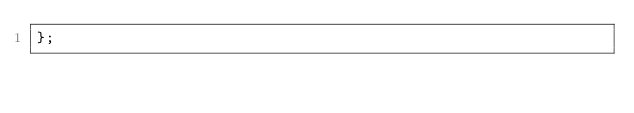<code> <loc_0><loc_0><loc_500><loc_500><_JavaScript_>};
</code> 